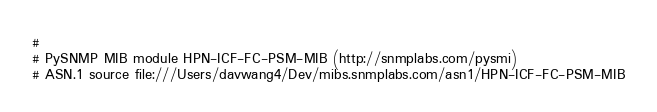Convert code to text. <code><loc_0><loc_0><loc_500><loc_500><_Python_>#
# PySNMP MIB module HPN-ICF-FC-PSM-MIB (http://snmplabs.com/pysmi)
# ASN.1 source file:///Users/davwang4/Dev/mibs.snmplabs.com/asn1/HPN-ICF-FC-PSM-MIB</code> 